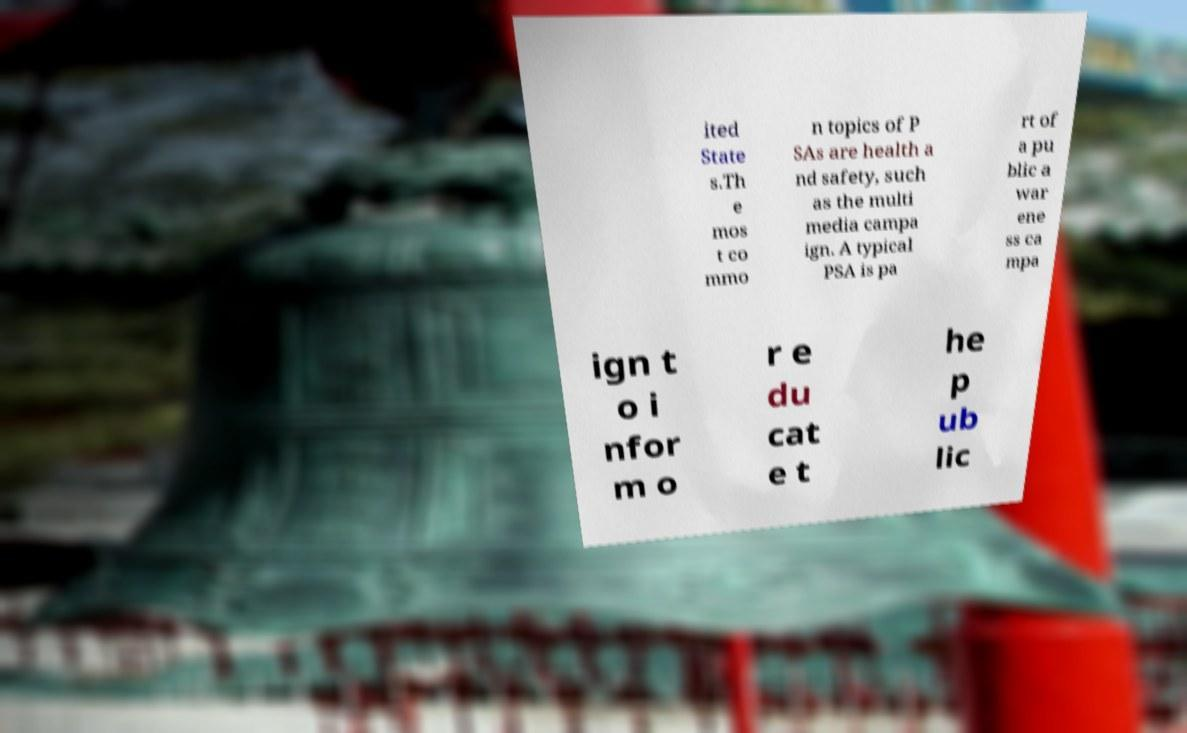Can you accurately transcribe the text from the provided image for me? ited State s.Th e mos t co mmo n topics of P SAs are health a nd safety, such as the multi media campa ign. A typical PSA is pa rt of a pu blic a war ene ss ca mpa ign t o i nfor m o r e du cat e t he p ub lic 